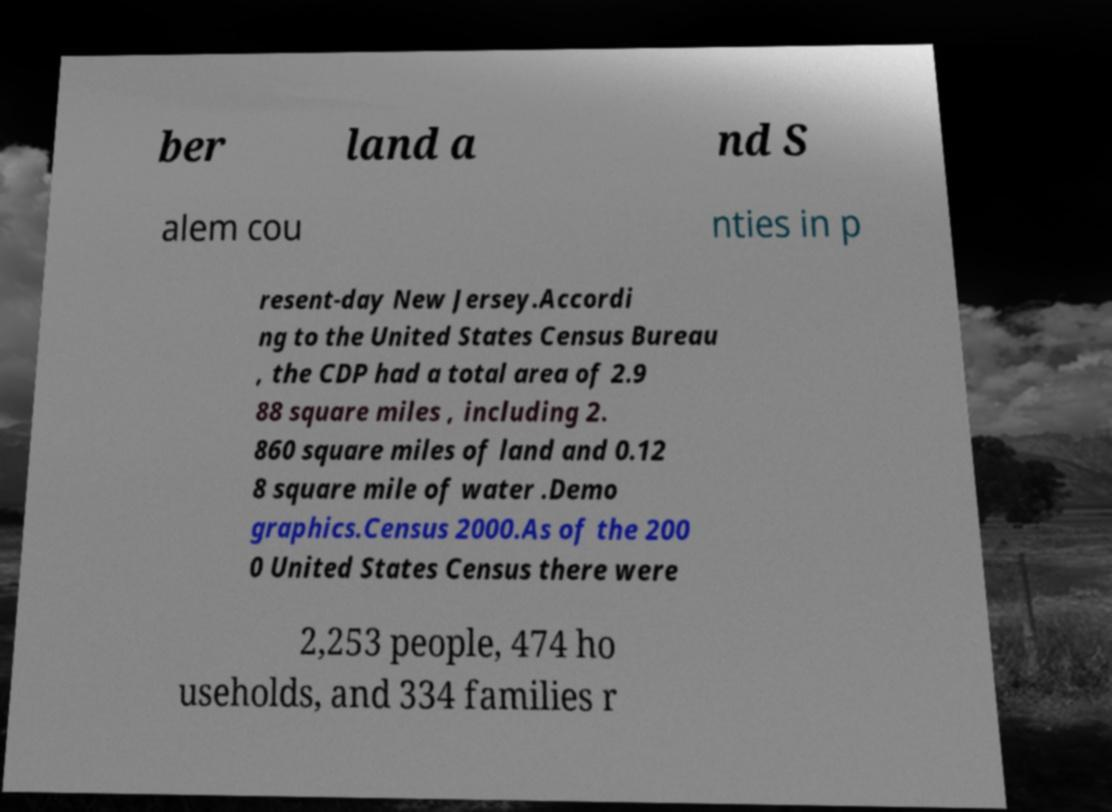Please read and relay the text visible in this image. What does it say? ber land a nd S alem cou nties in p resent-day New Jersey.Accordi ng to the United States Census Bureau , the CDP had a total area of 2.9 88 square miles , including 2. 860 square miles of land and 0.12 8 square mile of water .Demo graphics.Census 2000.As of the 200 0 United States Census there were 2,253 people, 474 ho useholds, and 334 families r 